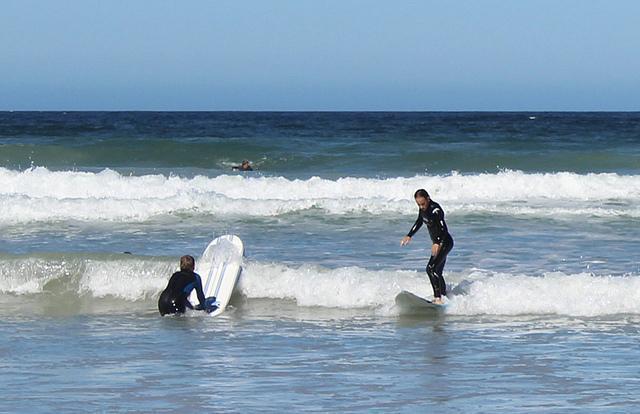How many people are in the water?
Give a very brief answer. 3. How many cars have a surfboard on them?
Give a very brief answer. 0. 